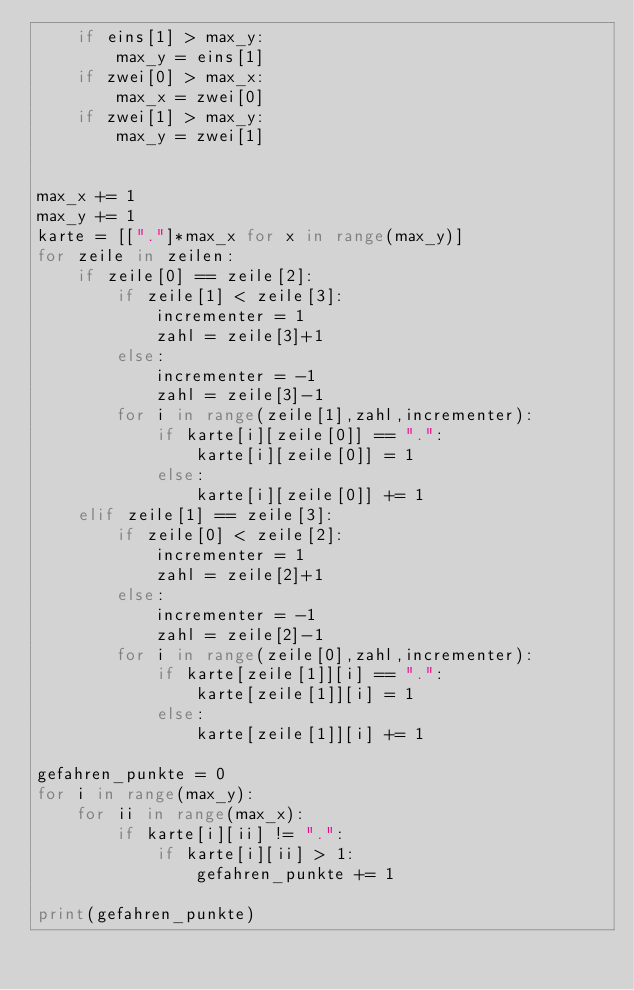Convert code to text. <code><loc_0><loc_0><loc_500><loc_500><_Python_>    if eins[1] > max_y:
        max_y = eins[1]
    if zwei[0] > max_x:
        max_x = zwei[0]
    if zwei[1] > max_y:
        max_y = zwei[1]


max_x += 1
max_y += 1
karte = [["."]*max_x for x in range(max_y)]
for zeile in zeilen:
    if zeile[0] == zeile[2]:
        if zeile[1] < zeile[3]:
            incrementer = 1
            zahl = zeile[3]+1
        else:
            incrementer = -1
            zahl = zeile[3]-1
        for i in range(zeile[1],zahl,incrementer):
            if karte[i][zeile[0]] == ".":
                karte[i][zeile[0]] = 1
            else:
                karte[i][zeile[0]] += 1
    elif zeile[1] == zeile[3]:
        if zeile[0] < zeile[2]:
            incrementer = 1
            zahl = zeile[2]+1
        else:
            incrementer = -1
            zahl = zeile[2]-1
        for i in range(zeile[0],zahl,incrementer):
            if karte[zeile[1]][i] == ".":
                karte[zeile[1]][i] = 1
            else:
                karte[zeile[1]][i] += 1

gefahren_punkte = 0
for i in range(max_y):
    for ii in range(max_x):
        if karte[i][ii] != ".":
            if karte[i][ii] > 1:
                gefahren_punkte += 1

print(gefahren_punkte)
</code> 